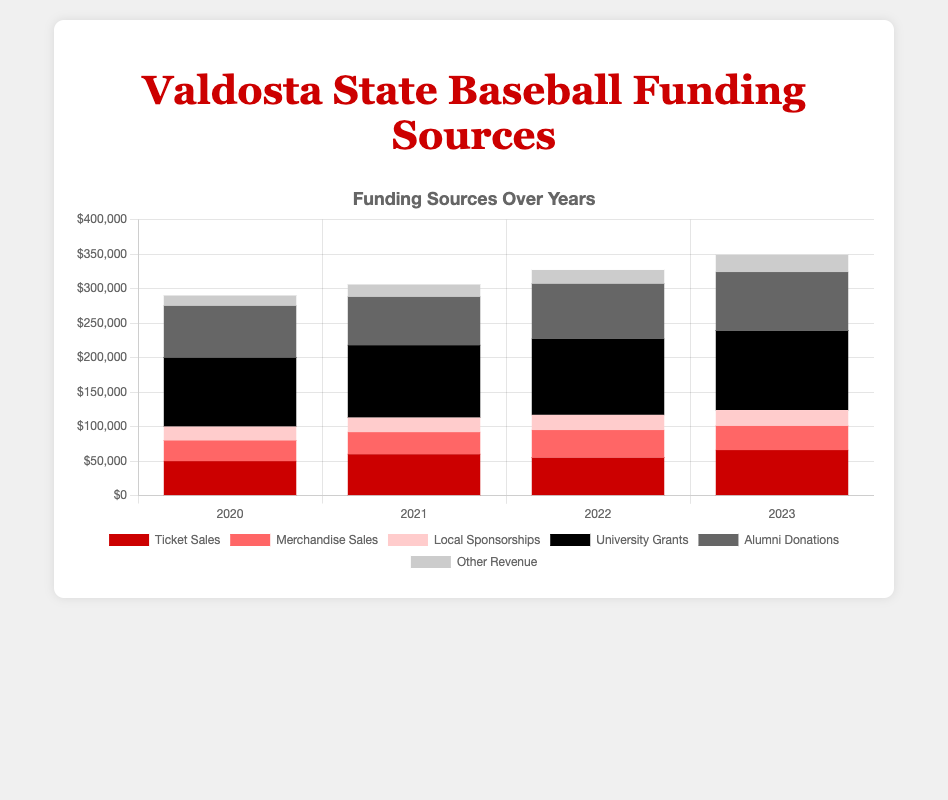What were the total ticket sales over the years? Sum the ticket sales for each year: 50000 + 60000 + 55000 + 66000. So, the total is 50000 + 60000 + 55000 + 66000 = 231000.
Answer: 231000 In which year were the alumni donations the highest? Compare the alumni donations for each year: 75000 (2020), 70000 (2021), 80000 (2022), 85000 (2023). The highest value is 85000 in 2023.
Answer: 2023 How did merchandise sales in 2022 compare to merchandise sales in 2020? Compare the values for 2022 and 2020: Merchandise sales in 2022 are 40000 and in 2020 are 30000. 40000 - 30000 = 10000. Merchandise sales in 2022 were $10,000 higher than in 2020.
Answer: 10000 higher Which funding source consistently contributed the highest amount across the years? Review each source for consistency across the years: University Grants: 100000 (2020), 105000 (2021), 110000 (2022), 115000 (2023). University Grants are consistently the highest.
Answer: University Grants How much did local sponsorships increase from 2020 to 2023? Subtract the 2020 value from the 2023 value: Local Sponsorships in 2020 were 20000 and in 2023 were 23000. 23000 - 20000 = 3000.
Answer: 3000 Which funding source had the largest increase in revenue from 2021 to 2022? Calculate the difference for each source from 2021 to 2022: Ticket Sales: -5000, Merchandise Sales: +8000, Local Sponsorships: +1000, University Grants: +5000, Alumni Donations: +10000, Other Revenue: +2000. Alumni Donations increased the most by 10000.
Answer: Alumni Donations What is the visual color representation of merchandise sales in the chart? Merchandise sales are represented in the chart with a light red color.
Answer: Light red What percentage of the total revenue in 2023 came from ticket sales? First, calculate the total revenue for 2023: 66000 (Ticket Sales) + 35000 (Merchandise Sales) + 23000 (Local Sponsorships) + 115000 (University Grants) + 85000 (Alumni Donations) + 25000 (Other Revenue) = 349000. Then, find the percentage contribution of Ticket Sales: (66000 / 349000) * 100 ≈ 18.91%.
Answer: 18.91% Which year saw the highest total revenue from all funding sources combined? Calculate the total revenue per year: 2020: 275000, 2021: 306000, 2022: 327000, 2023: 349000. The highest total revenue was in 2023 with 349000.
Answer: 2023 